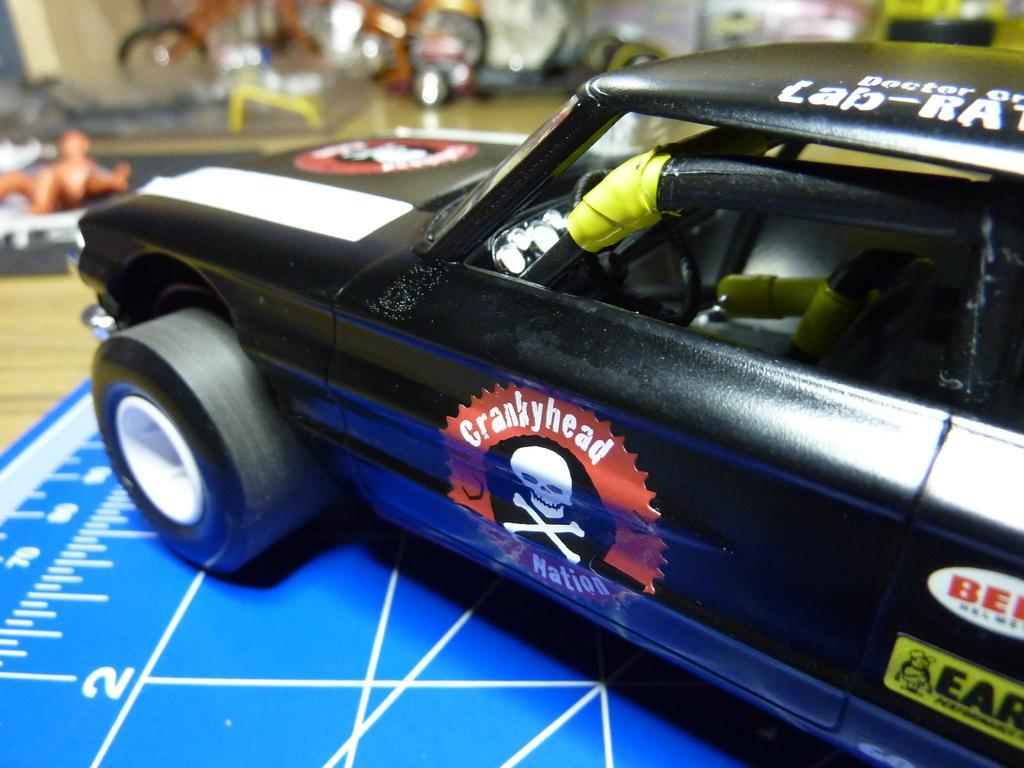Please provide a concise description of this image. In this image I can see a toy car which is in black color and I can see a blue color floor. 